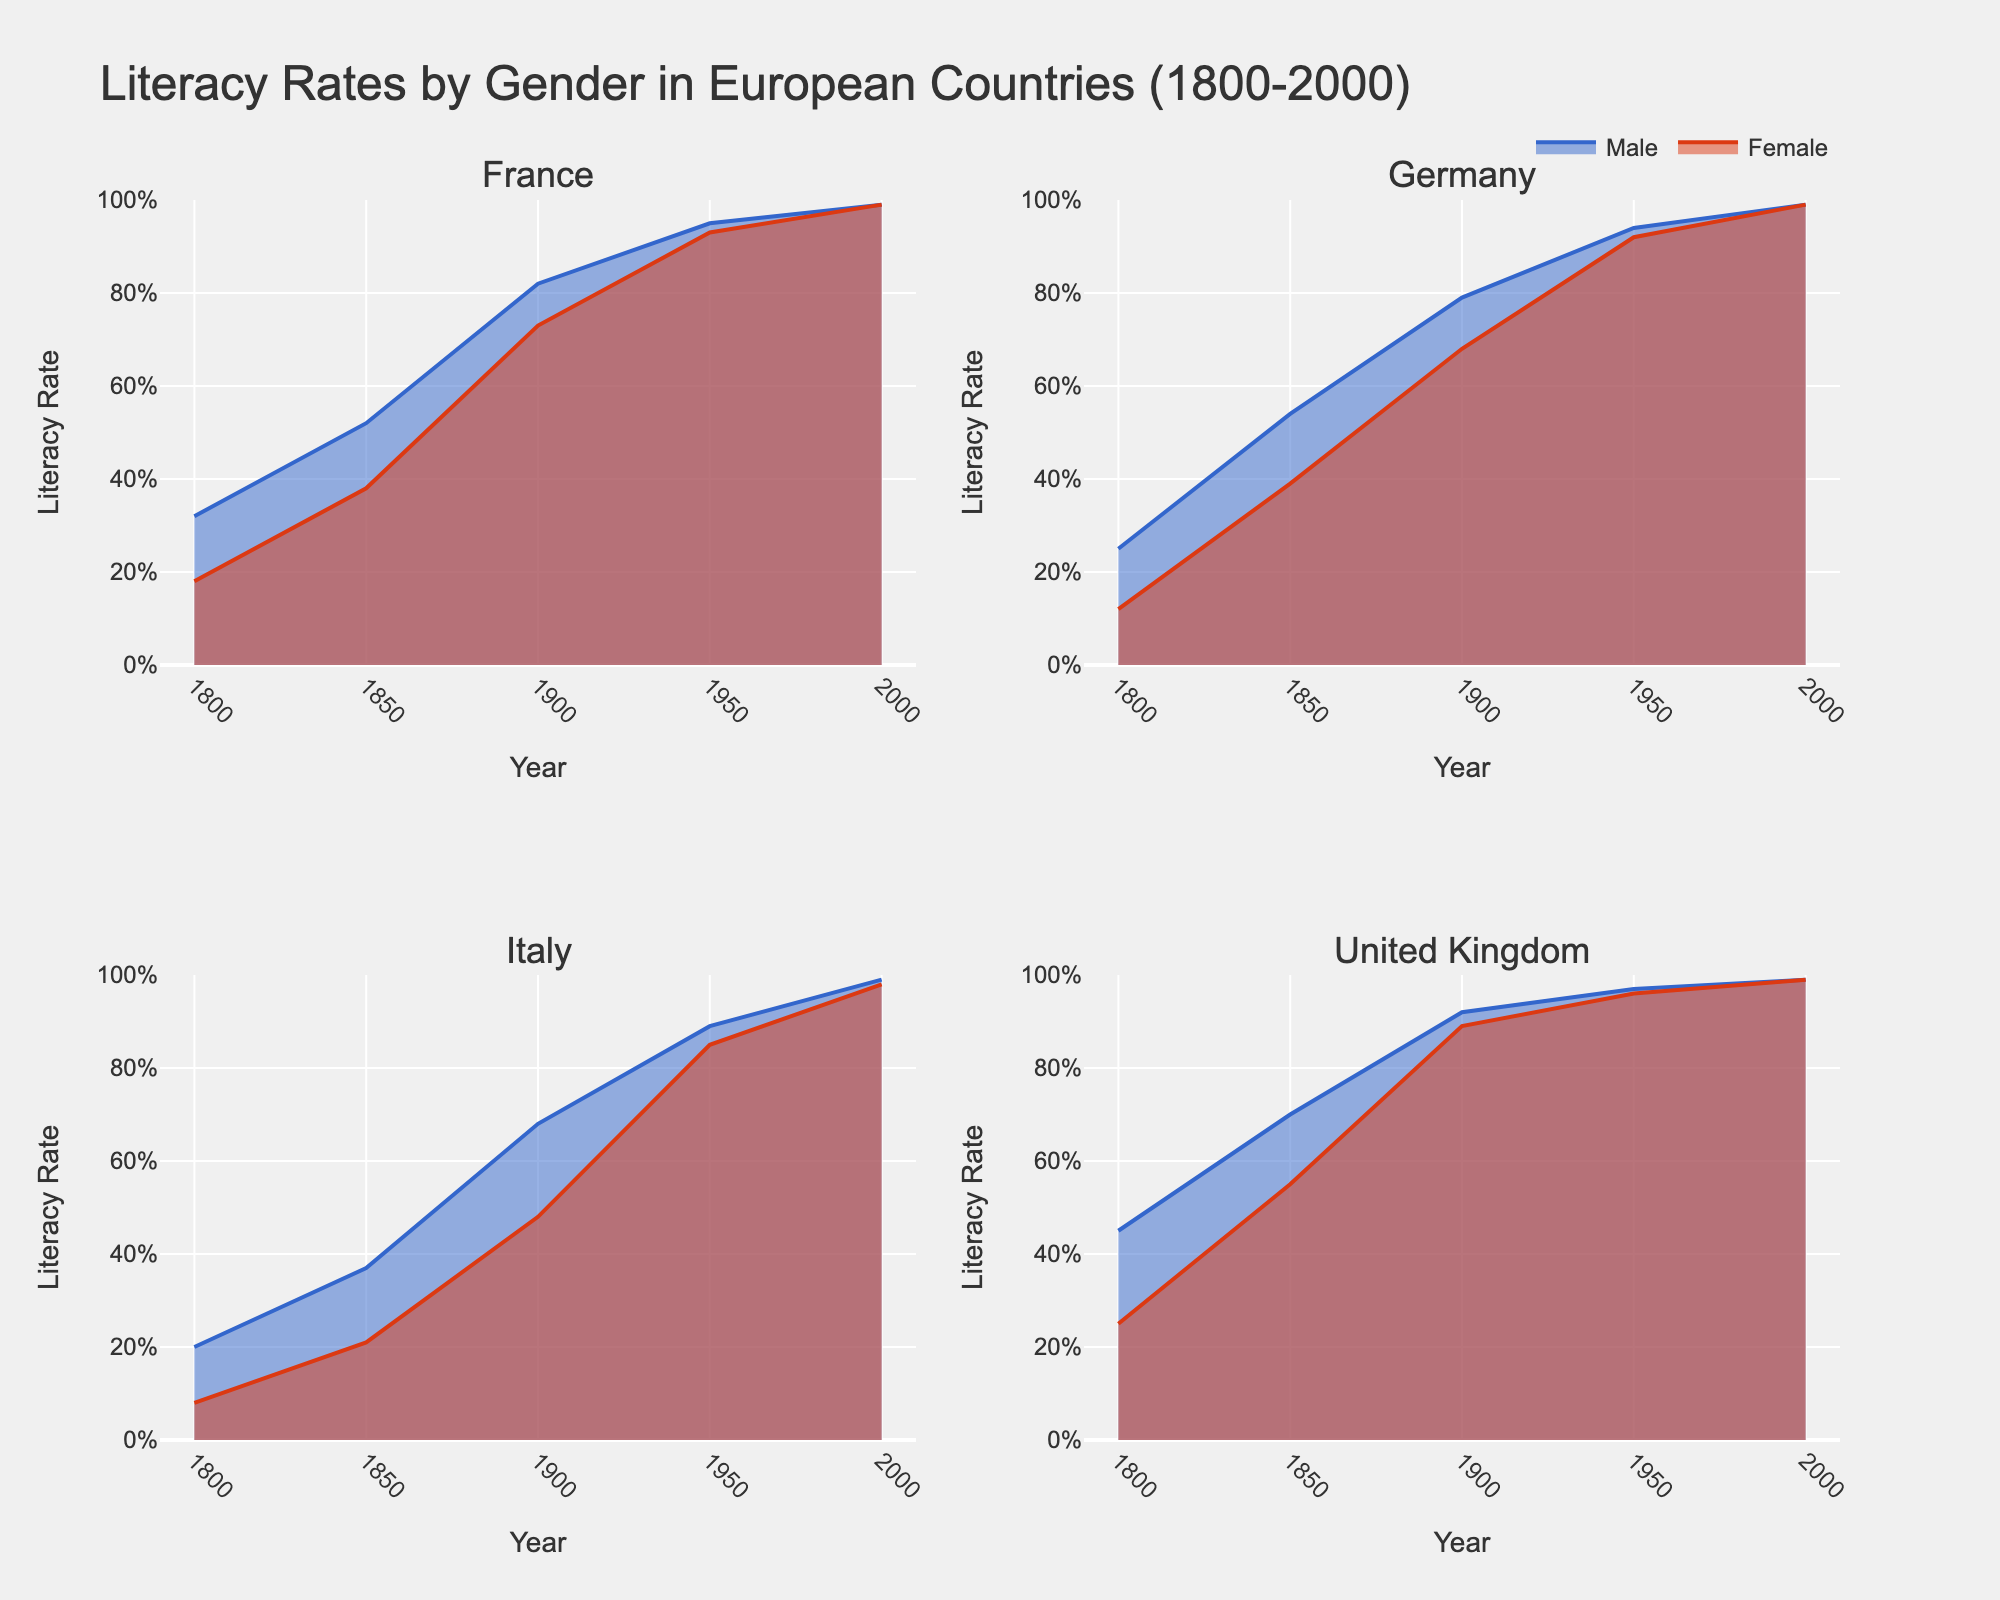What is the overall trend in literacy rates for males and females in France from 1800 to 2000? The literacy rates for both males and females in France show a consistent upward trend from 1800 to 2000. Initially, males had higher literacy rates than females, but by 2000, both genders reached nearly 100%.
Answer: An upward trend Which country had the highest female literacy rate in 1900? By examining the female literacy rates across all the subplots for the year 1900, we can see that the United Kingdom had the highest female literacy rate.
Answer: United Kingdom Compare the male literacy rates in Germany and the United Kingdom in 1850. Which country had a higher rate? Looking at the subplot for both Germany and the United Kingdom in 1850, the United Kingdom had a higher male literacy rate compared to Germany.
Answer: United Kingdom In which year did Italy see a significant rise in literacy rates for both males and females? In the subplot for Italy, a significant rise in literacy rates for both males and females is evident between 1850 and 1900.
Answer: Between 1850 and 1900 What is the literacy rate difference between males and females in Italy in the year 1950? From the subplot for Italy, the male literacy rate in 1950 is 0.89 and the female literacy rate is 0.85. The difference is 0.89 - 0.85 = 0.04.
Answer: 0.04 Which country achieved gender parity in literacy rates first, and in which year? By examining the timelines, the United Kingdom achieved gender parity in literacy rates first, around 1950 when both genders had nearly equal literacy rates.
Answer: United Kingdom, 1950 How did the literacy rates for German females change from 1850 to 1900? Observing the subplot for Germany, the female literacy rate increased from 0.39 in 1850 to 0.68 in 1900.
Answer: Increased Among the four countries shown, which had the lowest male literacy rate in 1800? Reviewing the male literacy rates in 1800 across all four subplots, Italy had the lowest male literacy rate at 0.20.
Answer: Italy What can you infer about the educational policies in France and Germany based on the change in literacy rates from 1850 to 1950? Based on the data, both countries show substantial increases in literacy rates for both genders between 1850 and 1950. This suggests that significant educational reforms likely occurred during this period.
Answer: Significant educational reforms 